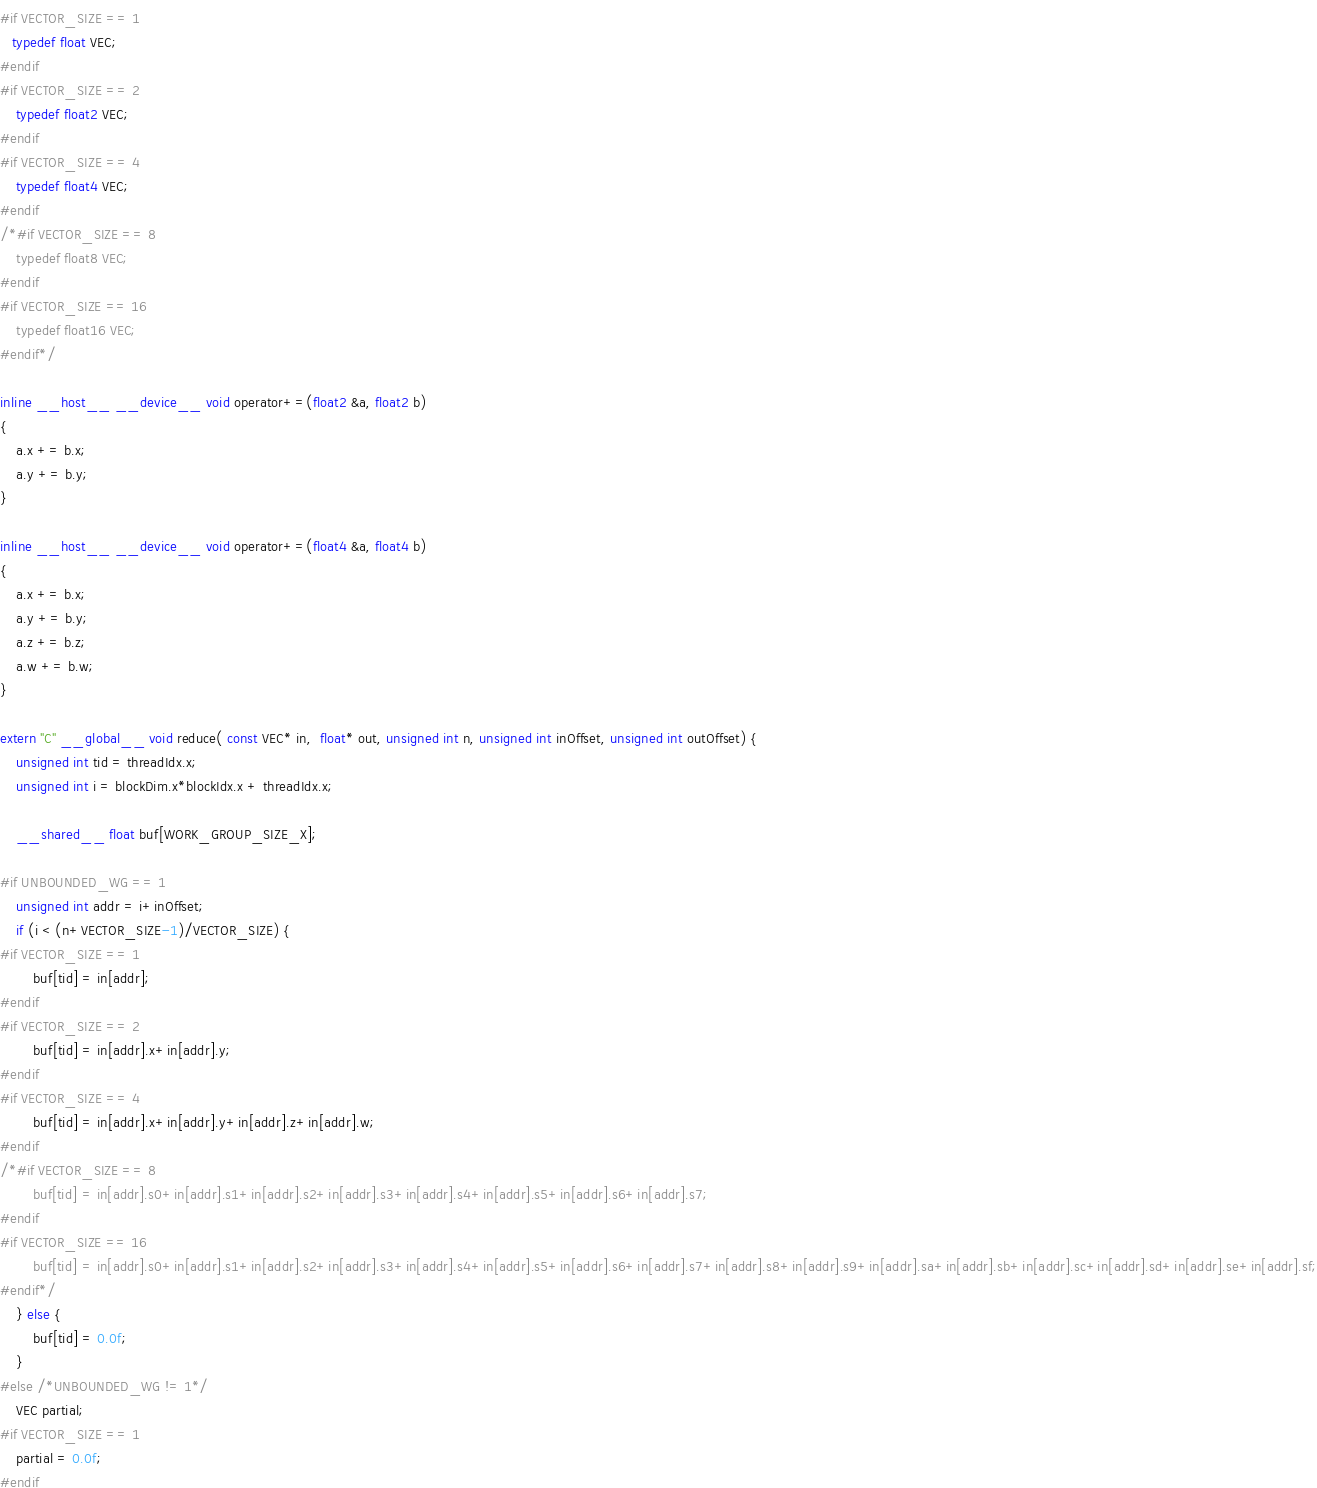<code> <loc_0><loc_0><loc_500><loc_500><_Cuda_>#if VECTOR_SIZE == 1
   typedef float VEC; 
#endif
#if VECTOR_SIZE == 2
    typedef float2 VEC;
#endif
#if VECTOR_SIZE == 4
    typedef float4 VEC;
#endif
/*#if VECTOR_SIZE == 8
    typedef float8 VEC;
#endif
#if VECTOR_SIZE == 16
    typedef float16 VEC;
#endif*/

inline __host__ __device__ void operator+=(float2 &a, float2 b)
{
    a.x += b.x;
    a.y += b.y;
}

inline __host__ __device__ void operator+=(float4 &a, float4 b)
{
    a.x += b.x;
    a.y += b.y;
    a.z += b.z;
    a.w += b.w;
}

extern "C" __global__ void reduce( const VEC* in,  float* out, unsigned int n, unsigned int inOffset, unsigned int outOffset) {
    unsigned int tid = threadIdx.x;
    unsigned int i = blockDim.x*blockIdx.x + threadIdx.x;

    __shared__ float buf[WORK_GROUP_SIZE_X];

#if UNBOUNDED_WG == 1
    unsigned int addr = i+inOffset;
    if (i < (n+VECTOR_SIZE-1)/VECTOR_SIZE) {
#if VECTOR_SIZE == 1
        buf[tid] = in[addr];
#endif
#if VECTOR_SIZE == 2
        buf[tid] = in[addr].x+in[addr].y;
#endif
#if VECTOR_SIZE == 4
        buf[tid] = in[addr].x+in[addr].y+in[addr].z+in[addr].w;
#endif
/*#if VECTOR_SIZE == 8
        buf[tid] = in[addr].s0+in[addr].s1+in[addr].s2+in[addr].s3+in[addr].s4+in[addr].s5+in[addr].s6+in[addr].s7;
#endif
#if VECTOR_SIZE == 16
        buf[tid] = in[addr].s0+in[addr].s1+in[addr].s2+in[addr].s3+in[addr].s4+in[addr].s5+in[addr].s6+in[addr].s7+in[addr].s8+in[addr].s9+in[addr].sa+in[addr].sb+in[addr].sc+in[addr].sd+in[addr].se+in[addr].sf;
#endif*/
    } else {
        buf[tid] = 0.0f;
    }
#else /*UNBOUNDED_WG != 1*/
    VEC partial;
#if VECTOR_SIZE == 1
    partial = 0.0f;
#endif</code> 